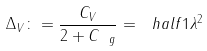Convert formula to latex. <formula><loc_0><loc_0><loc_500><loc_500>\Delta _ { V } \colon = \frac { C _ { V } } { 2 + C _ { \ g } } = \ h a l f { 1 } \| \lambda \| ^ { 2 }</formula> 